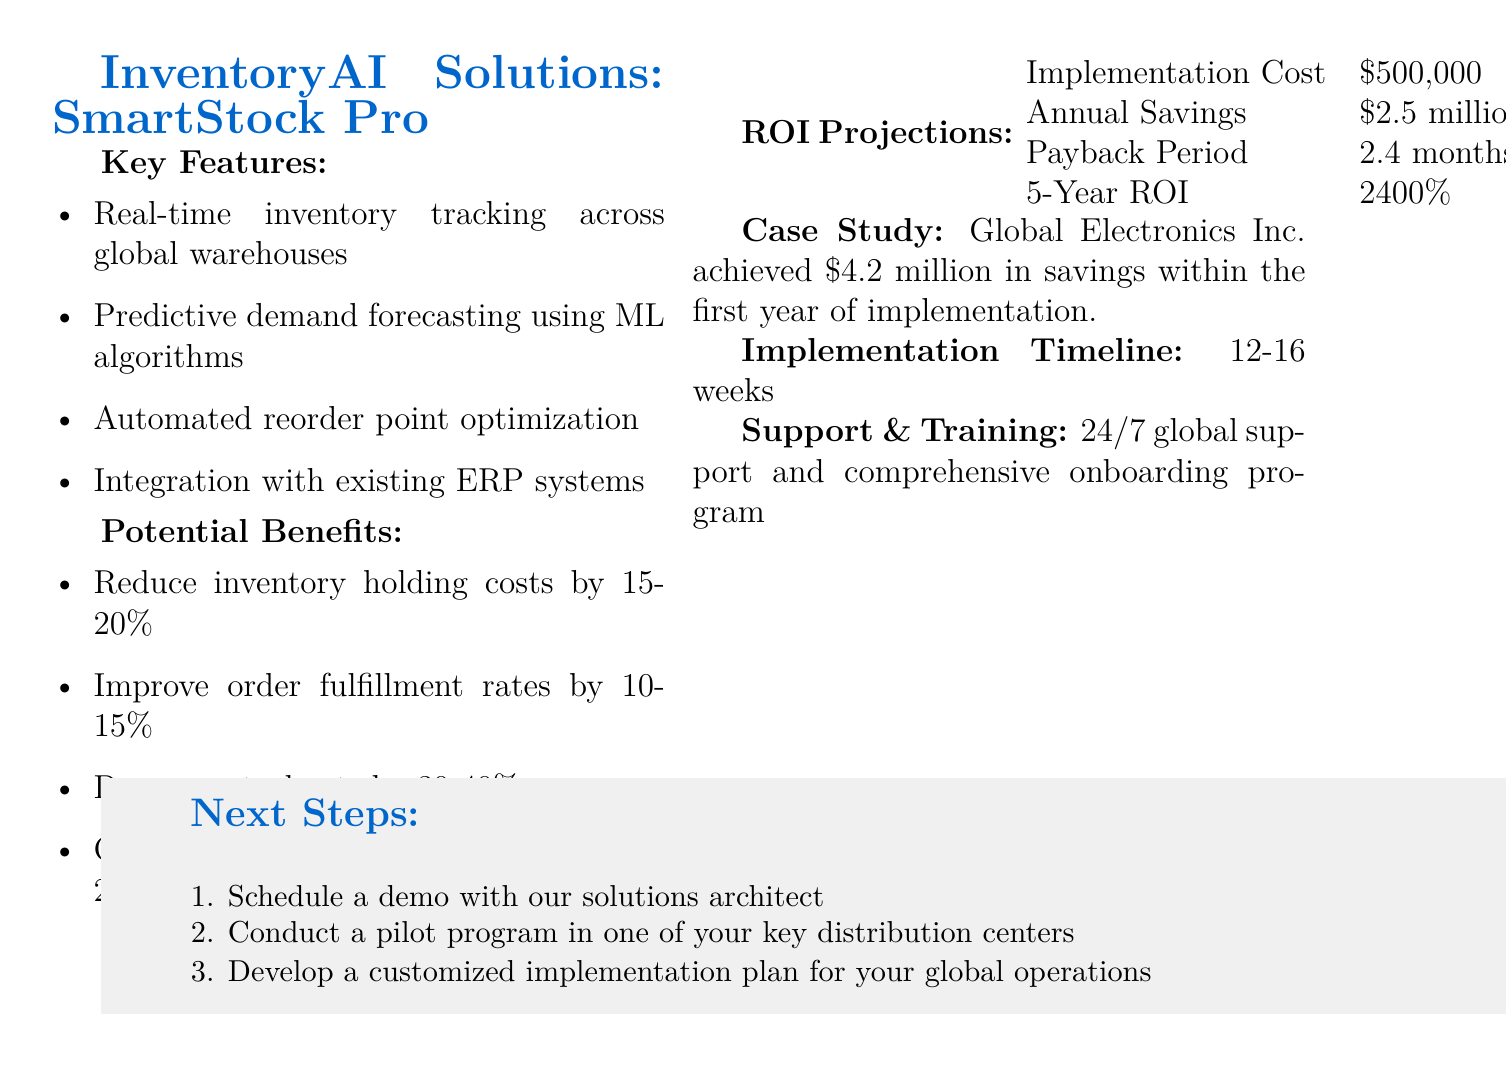What is the vendor name? The vendor is the company providing the proposal, which is mentioned in the document.
Answer: InventoryAI Solutions What is the implementation cost? The document specifically states the cost required for implementation of the system.
Answer: $500,000 What is the annual savings projected? The document outlines the projected savings that can be achieved annually as per the proposal.
Answer: $2.5 million What is the payback period for the investment? The payback period is the time it will take to recover the initial investment, as mentioned in the proposal.
Answer: 2.4 months What is a key feature of the SmartStock Pro system? The document lists several features of the inventory management system.
Answer: Real-time inventory tracking across global warehouses How much can inventory holding costs be reduced? The document provides a range of potential cost reductions, indicating expected savings from the system.
Answer: 15-20% What is the case study company's name? The document provides a real-world example to support the proposal and mentions the company involved.
Answer: Global Electronics Inc What is the implementation timeline for the system? The timeline for incorporating the system into operations is explicitly stated in the document.
Answer: 12-16 weeks What are the next steps proposed? The document outlines steps to proceed further with the proposal, indicating actions to take.
Answer: Schedule a demo with our solutions architect 